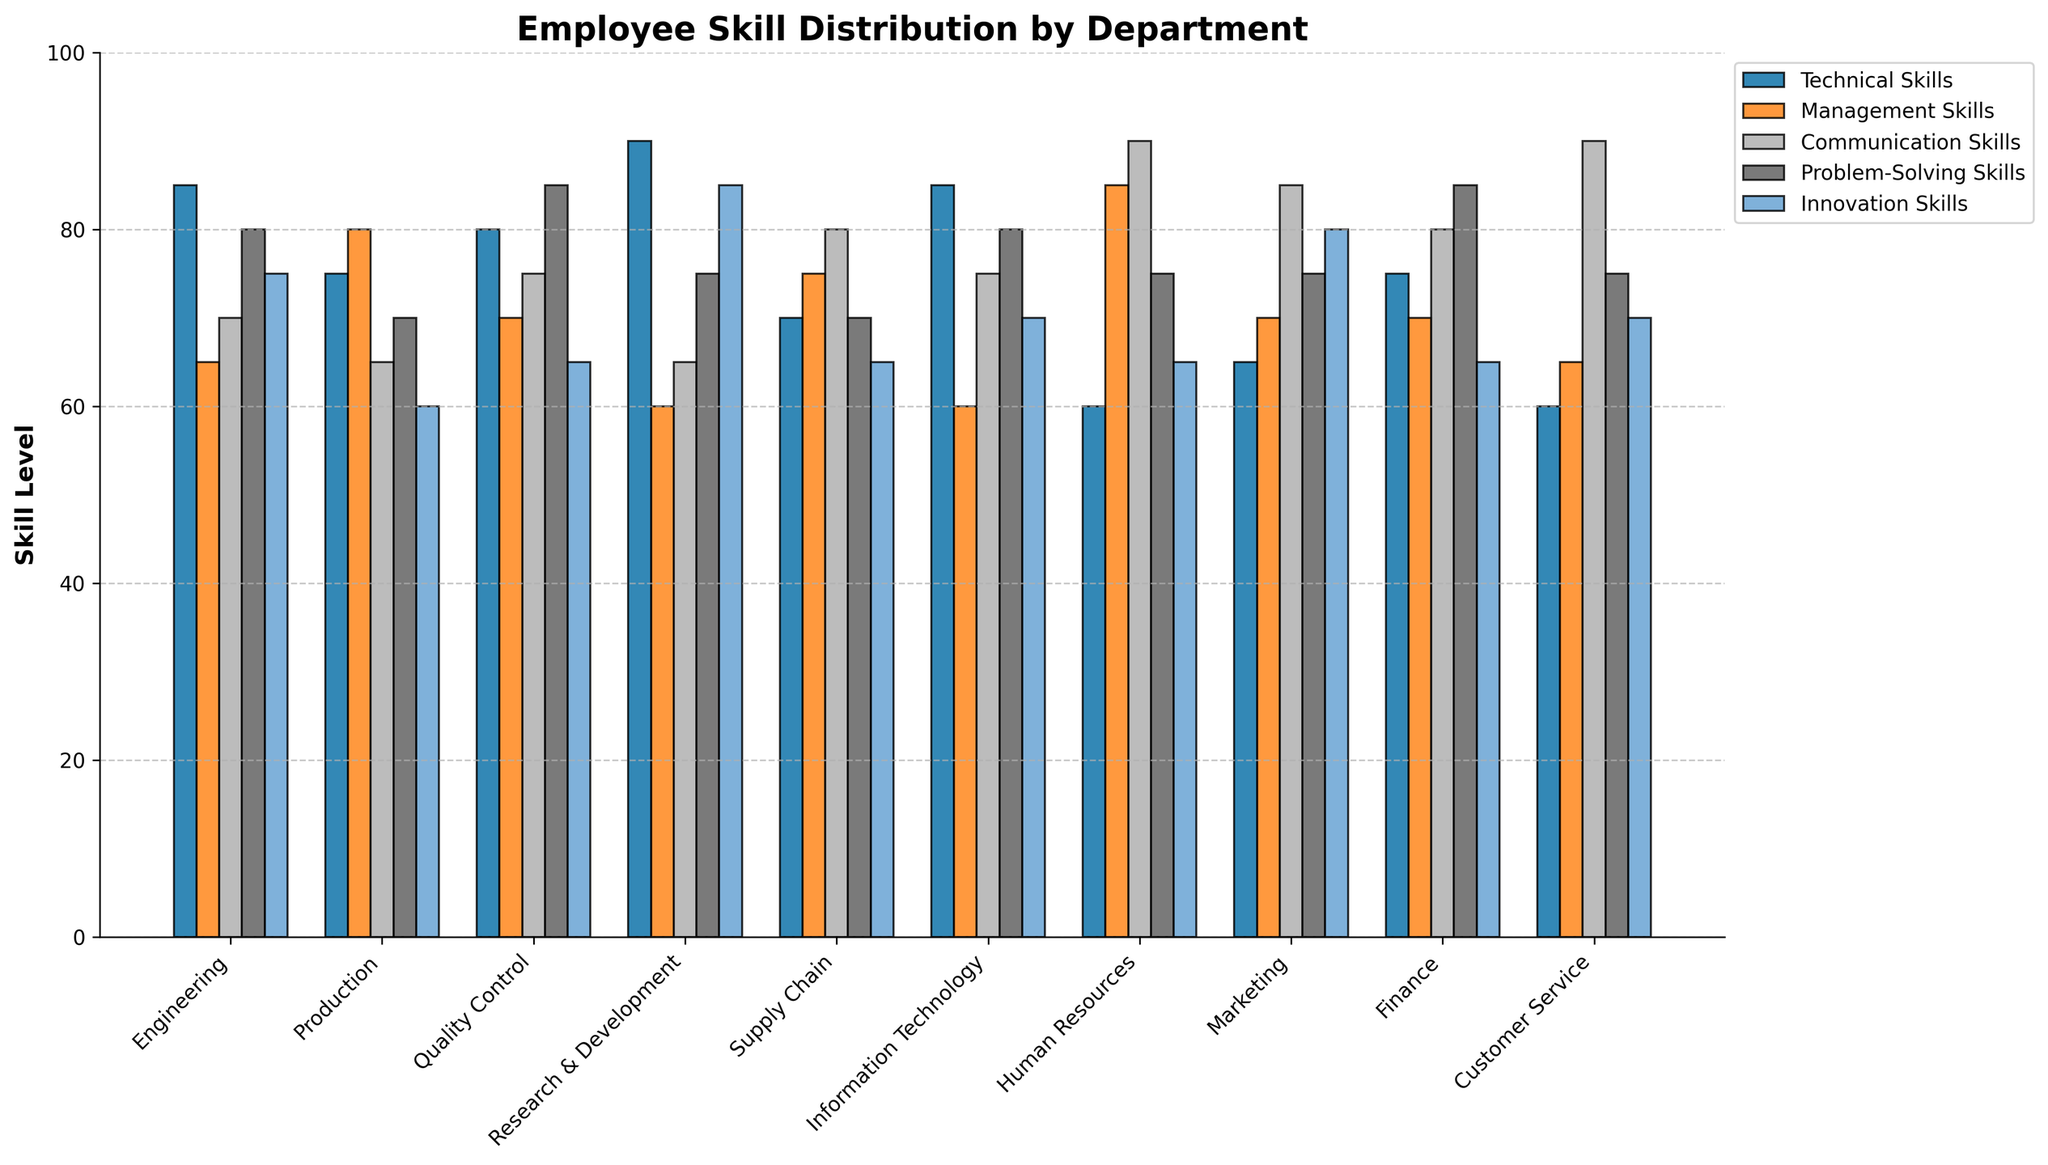What is the department with the highest average skill level? Calculate the average skill level for each department and identify the highest. For example, Engineering's average is (85+65+70+80+75)/5 = 75.5, whereas R&D's average is (90+60+65+75+85)/5 = 75.
Answer: Engineering Which department has the lowest problem-solving skills? Compare the problem-solving skills across all departments. For instance, Production has 70 while Engineering has 80. The department with the smallest value is identified.
Answer: Production Which skill is most improved in Human Resources compared to Production? Compare the skill levels of both departments for each skill. For example, Management Skills in HR is 85 compared to 80 in Production, an improvement of 5 points. Repeat for all skills to find the greatest improvement.
Answer: Management Skills Between Engineering and IT, which department has better communication skills? Compare Communication Skills of Engineering (70) and Information Technology (75).
Answer: Information Technology Which department has the most balanced skill levels (least variance among the five skills measured)? Calculate the range (difference between the highest and lowest values) for each department. For example, Engineering has a range of 85-65=20, and HR has 90-65=25. The department with the smallest range is the answer.
Answer: Engineering What is the average innovation skill level across all departments? Sum the innovation skill levels and divide by the number of departments: (75+60+65+85+65+70+65+80+65+70)/10 = 69
Answer: 69 Which department excels the most in technical skills but lacks in management skills? Compare the Technical Skills and Management Skills of all departments. Identify which department has the highest technical skills and the lowest management skills separately and find commonalities.
Answer: Research & Development Are communication skills in Marketing and Customer Service above average when compared to other departments? Calculate the average communication skills: (70+65+75+65+80+75+90+85+80+90)/10 = 77. Compare this value with Marketing (85) and Customer Service (90).
Answer: Yes Which two departments have the highest combined problem-solving skills? Add problem-solving skills for each department in pairs and identify the two departments which, when combined, give the highest value. For example, Engineering (80) + Quality Control (85) = 165, higher than Production (70) + IT (80) = 150.
Answer: Quality Control and Finance How many departments have innovation skills below 70? Survey the Innovation Skills across all departments and count how many are below 70: Production (60), Quality Control (65), Supply Chain (65), and several others.
Answer: 5 